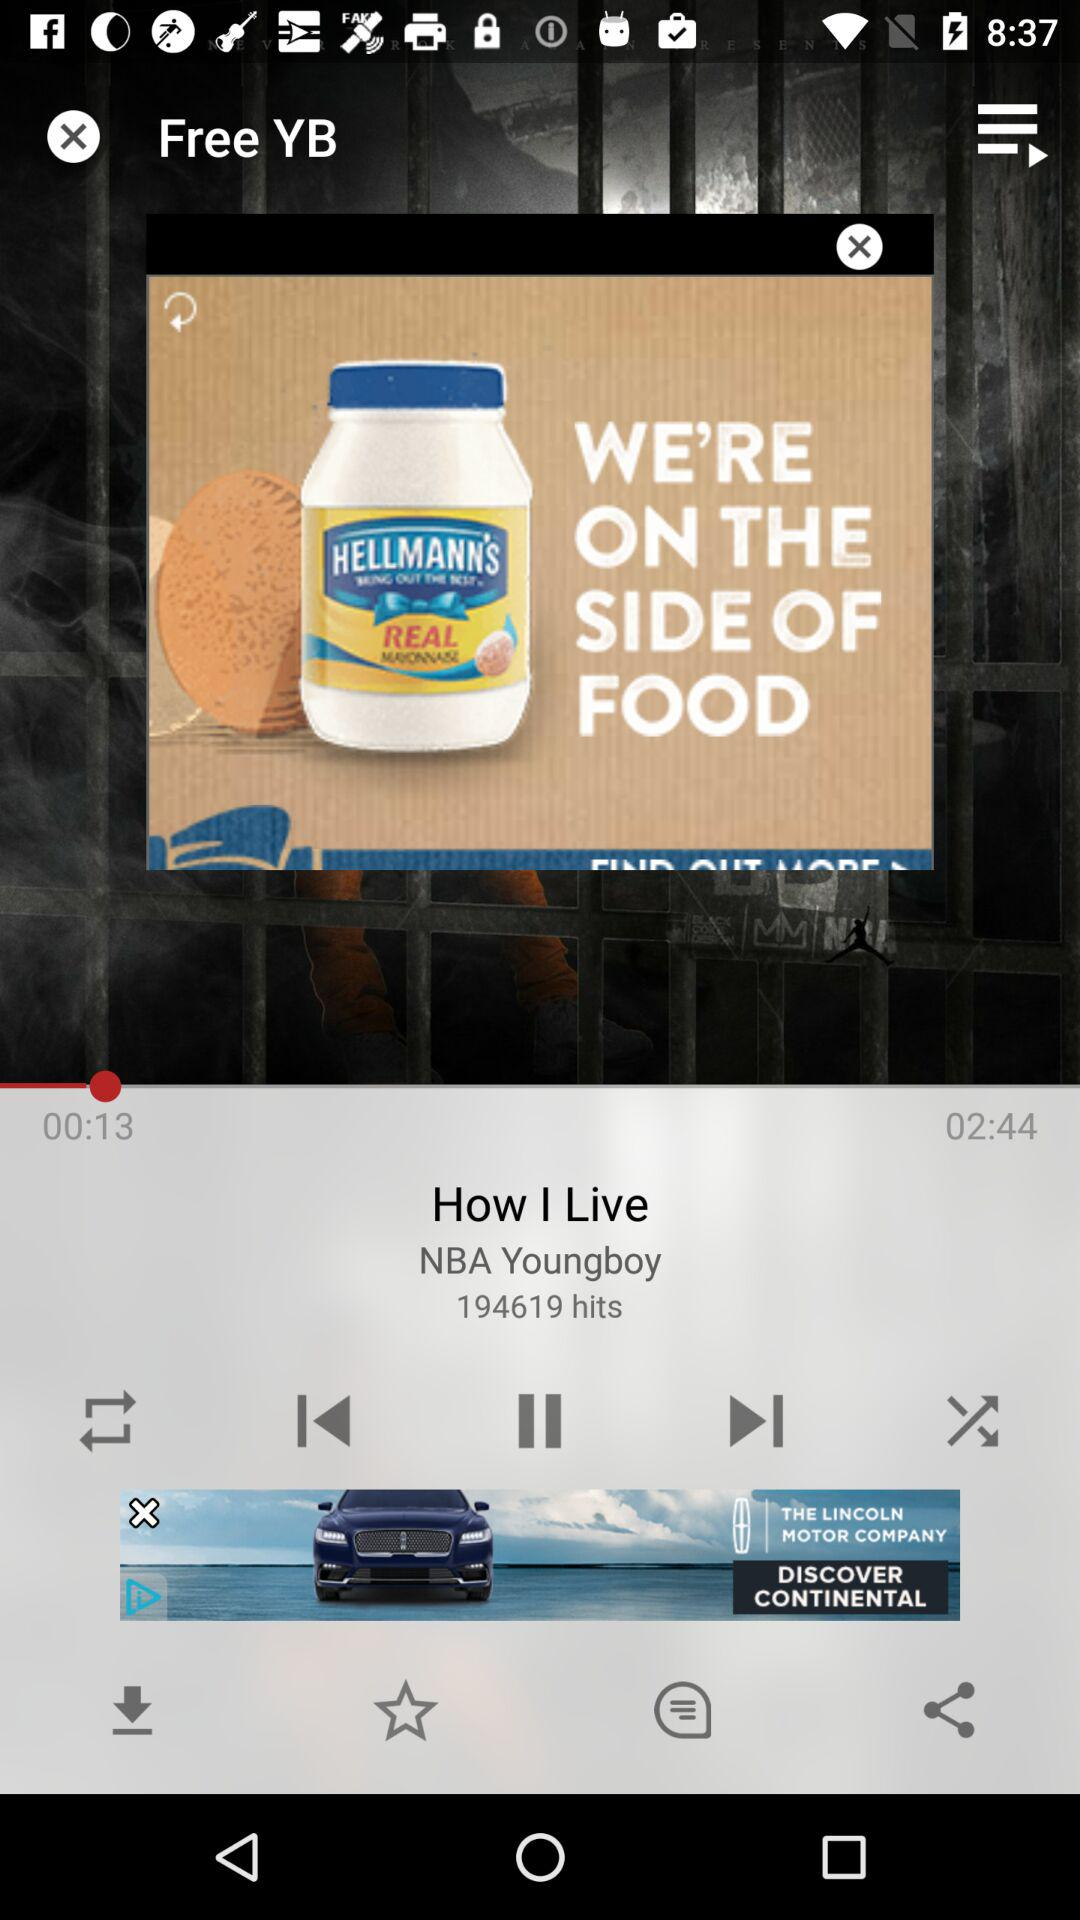What is the time duration of a song? The time duration of a song is 02:44. 